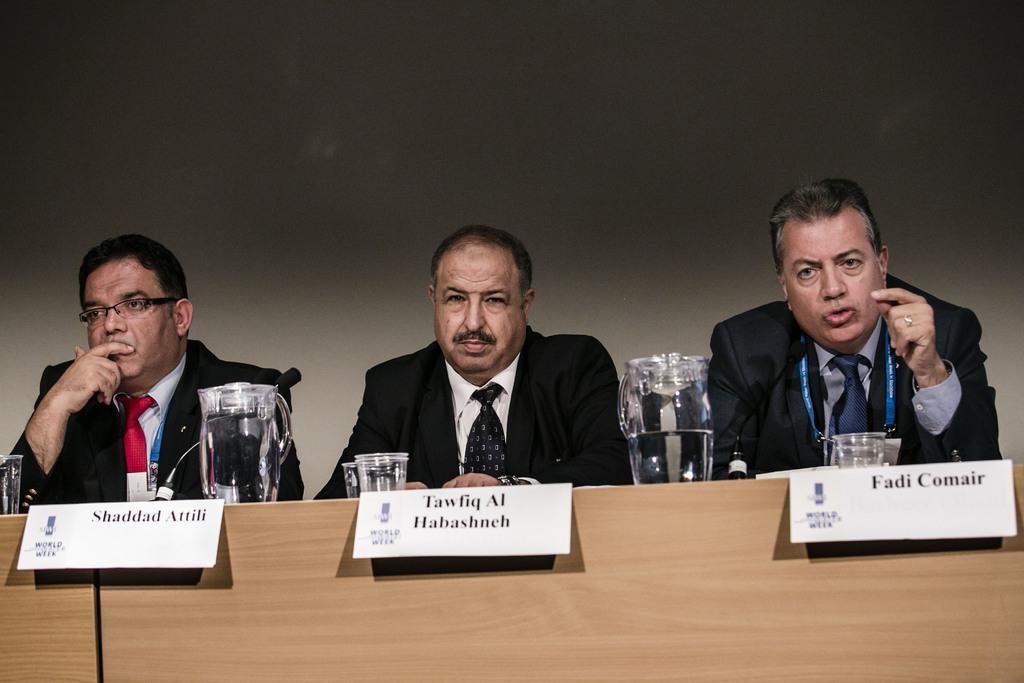Could you give a brief overview of what you see in this image? In this image there are three persons sitting , there are jugs, glasses,name plates , mikes on the table, and in the background there is a wall. 